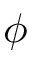<formula> <loc_0><loc_0><loc_500><loc_500>\phi</formula> 